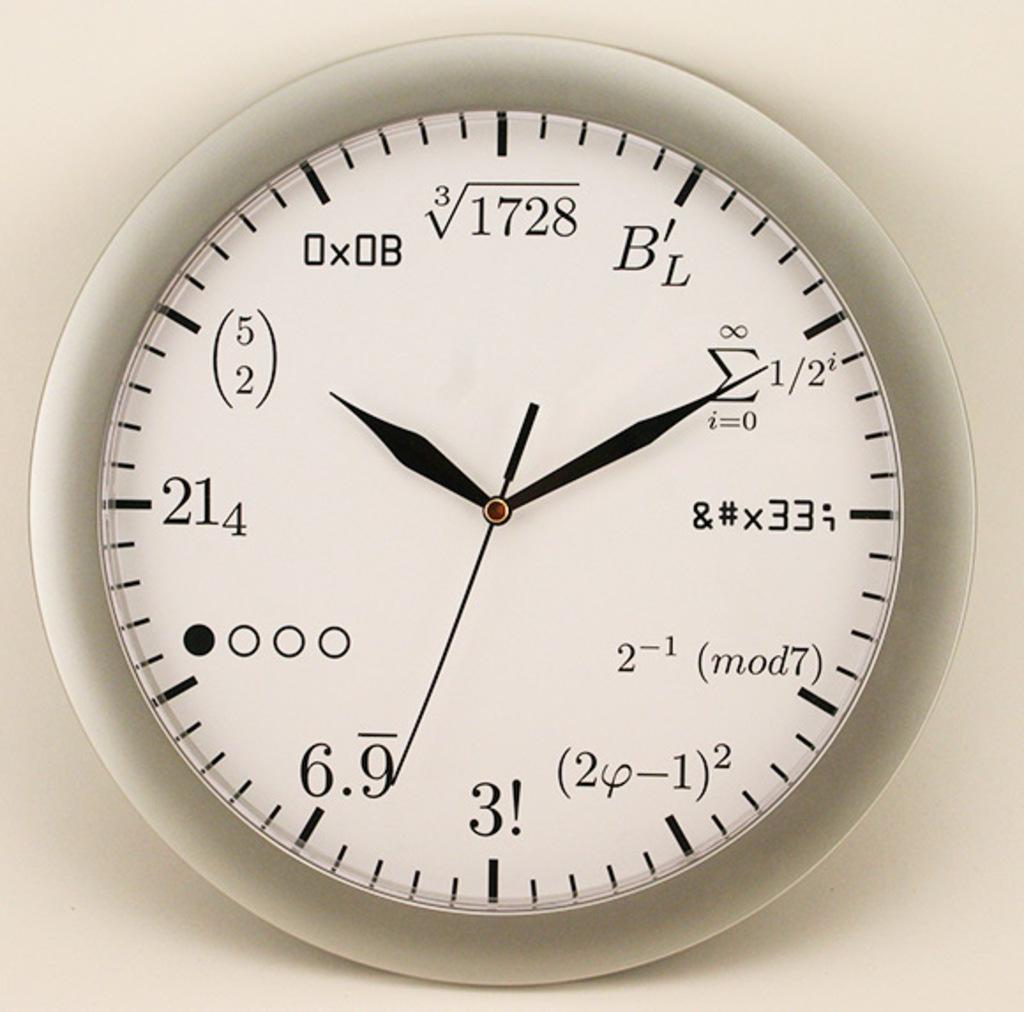What time is displayed on the clock?
Your answer should be very brief. 10:10. What number and character replaces the 6 spot on the clock?
Make the answer very short. 3!. 